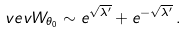<formula> <loc_0><loc_0><loc_500><loc_500>\ v e v { W _ { \theta _ { 0 } } } \sim e ^ { \sqrt { \lambda ^ { \prime } } } + e ^ { - \sqrt { \lambda ^ { \prime } } } \, .</formula> 